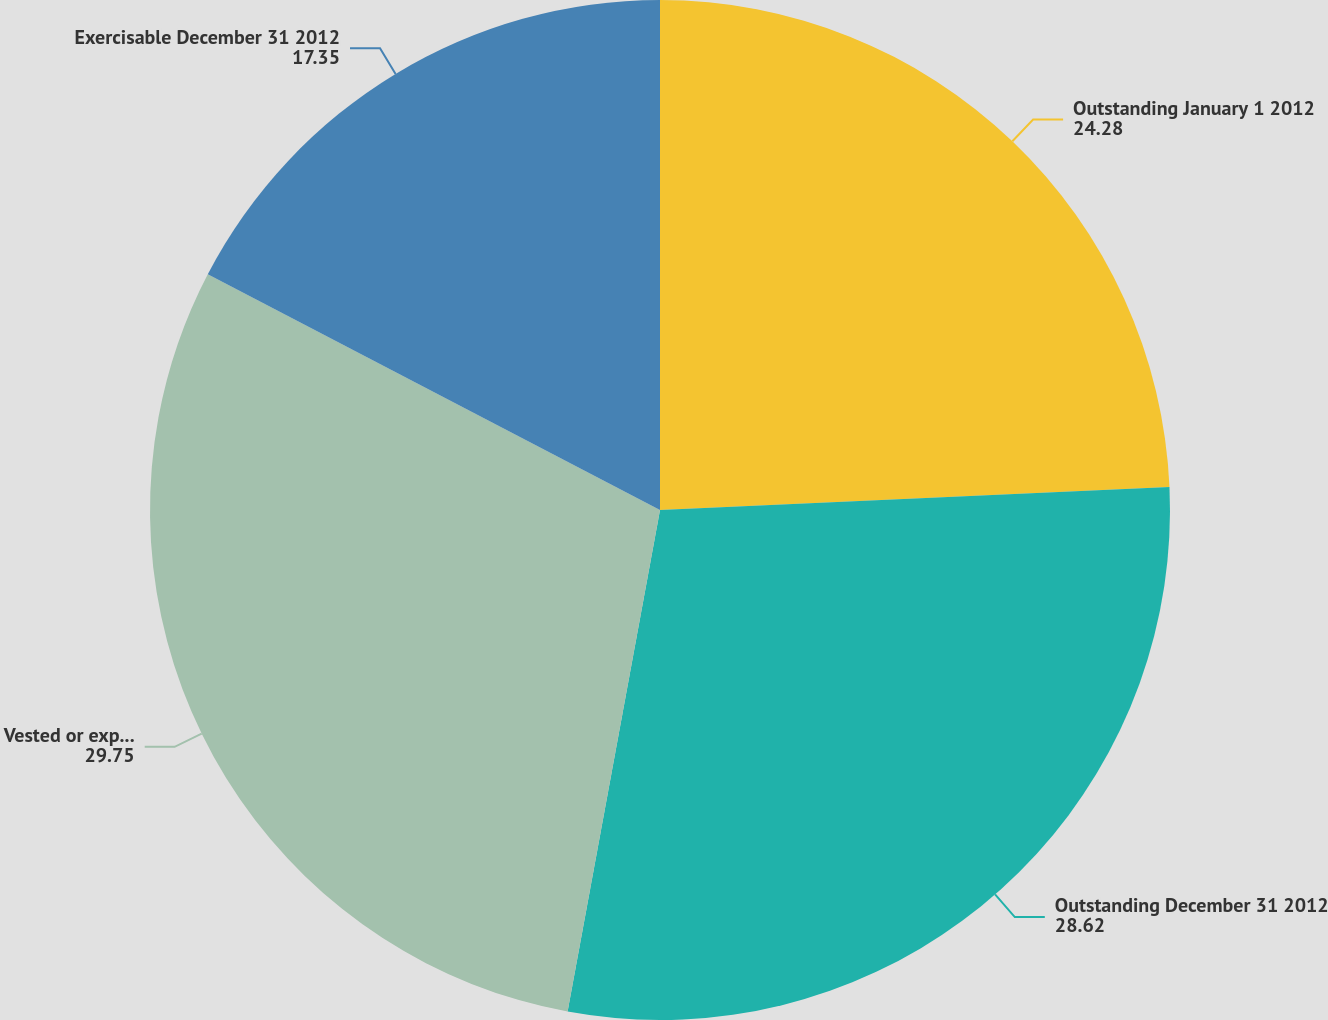<chart> <loc_0><loc_0><loc_500><loc_500><pie_chart><fcel>Outstanding January 1 2012<fcel>Outstanding December 31 2012<fcel>Vested or expected to vest<fcel>Exercisable December 31 2012<nl><fcel>24.28%<fcel>28.62%<fcel>29.75%<fcel>17.35%<nl></chart> 